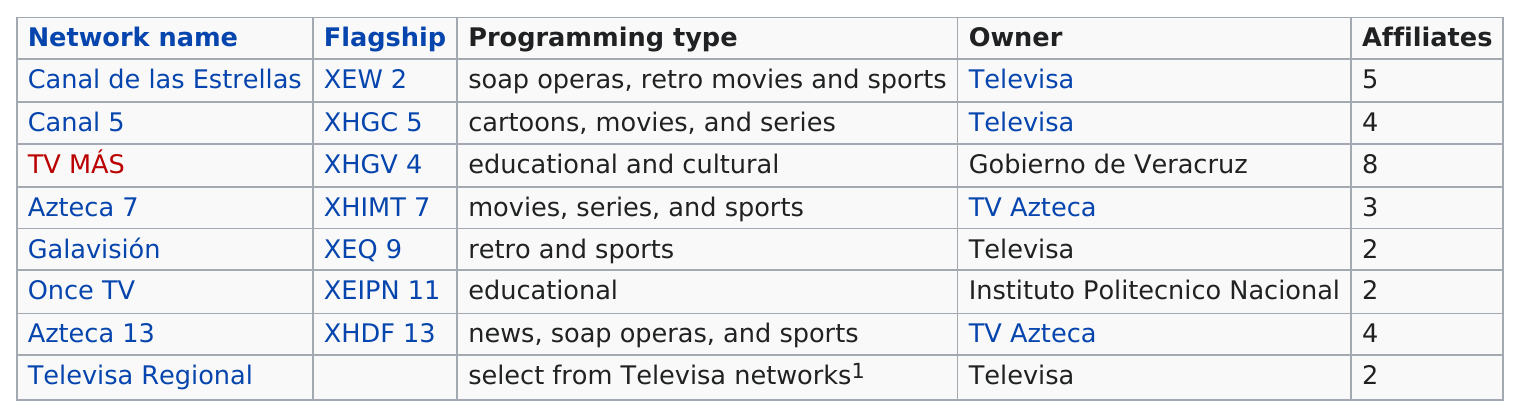Identify some key points in this picture. It is the case that two networks currently air soap operas. TV Azteca owns a total of 2 stations. There are four stations that have more affiliates than Azteca 7. TV MÁS has the most number of affiliates. There is at least one television network that has more affiliates than Canal de las Estrellas. 